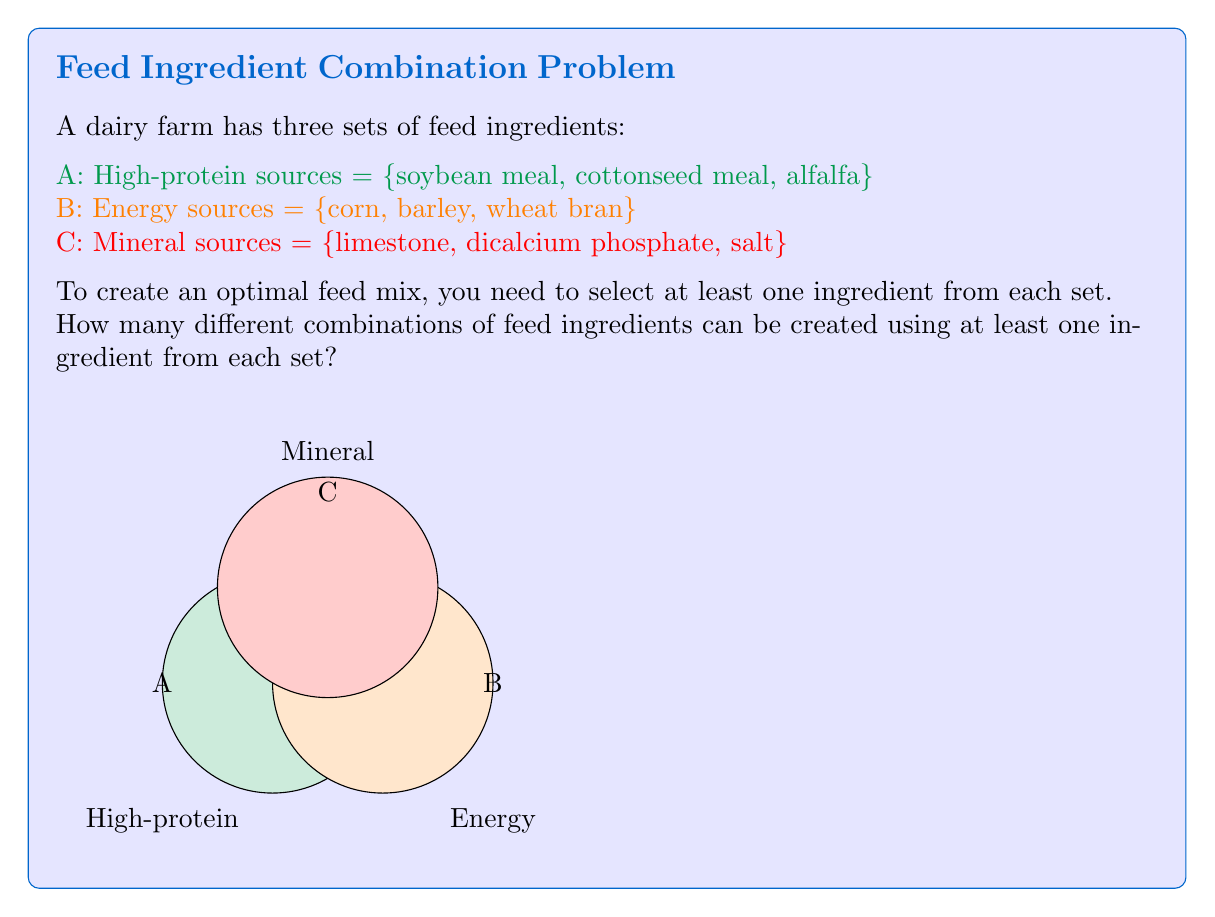Can you answer this question? To solve this problem, we'll use the principle of inclusion-exclusion and set theory.

Step 1: Calculate the total number of possible combinations for each set.
A: $2^3 - 1 = 7$ (excluding the empty set)
B: $2^3 - 1 = 7$
C: $2^3 - 1 = 7$

Step 2: Use the multiplication principle to find the total number of combinations using at least one ingredient from each set.

$$ \text{Total combinations} = 7 \times 7 \times 7 = 343 $$

This calculation gives us all possible combinations where we choose at least one ingredient from each set.

Step 3: Verify the result using set theory notation.

Let $|A|$, $|B|$, and $|C|$ represent the number of non-empty subsets of each set.

$$ |A \cap B \cap C| = (2^{|A|} - 1) \times (2^{|B|} - 1) \times (2^{|C|} - 1) $$
$$ = (2^3 - 1) \times (2^3 - 1) \times (2^3 - 1) $$
$$ = 7 \times 7 \times 7 = 343 $$

This confirms our initial calculation.
Answer: 343 combinations 